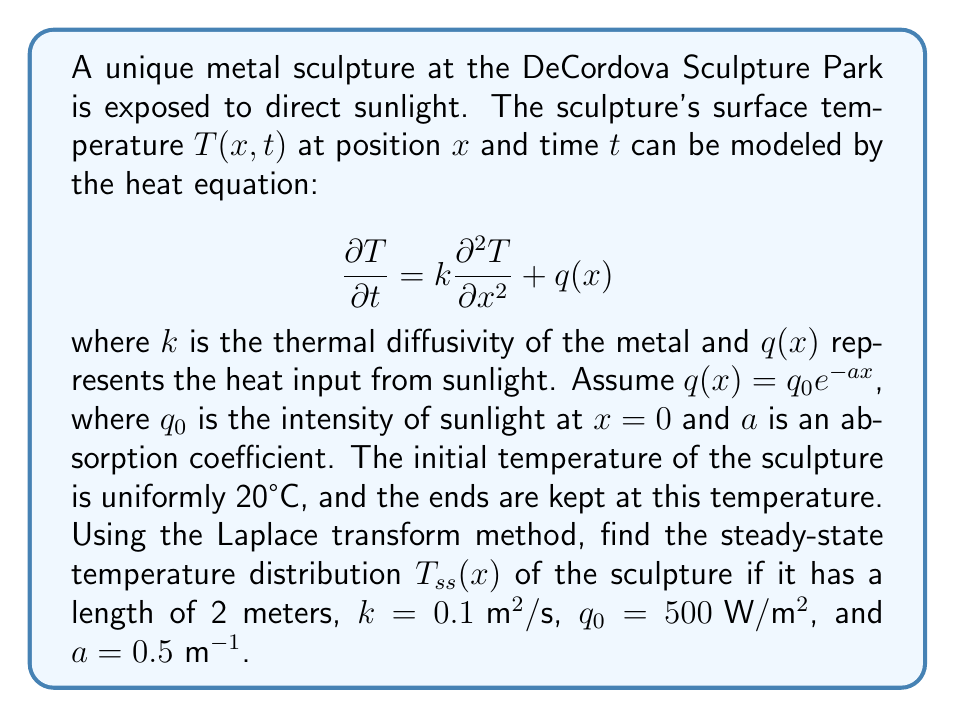Could you help me with this problem? To solve this problem, we'll follow these steps:

1) First, we need to find the steady-state equation by setting $\frac{\partial T}{\partial t} = 0$:

   $$0 = k\frac{d^2 T_{ss}}{dx^2} + q_0e^{-ax}$$

2) Rearranging the equation:

   $$\frac{d^2 T_{ss}}{dx^2} = -\frac{q_0}{k}e^{-ax}$$

3) Taking the Laplace transform of both sides with respect to $x$:

   $$s^2\mathcal{L}\{T_{ss}\} - sT_{ss}(0) - T_{ss}'(0) = -\frac{q_0}{k}\mathcal{L}\{e^{-ax}\}$$

4) We know that $\mathcal{L}\{e^{-ax}\} = \frac{1}{s+a}$, so:

   $$s^2\mathcal{L}\{T_{ss}\} - sT_{ss}(0) - T_{ss}'(0) = -\frac{q_0}{k}\frac{1}{s+a}$$

5) Solving for $\mathcal{L}\{T_{ss}\}$:

   $$\mathcal{L}\{T_{ss}\} = \frac{T_{ss}(0)}{s} + \frac{T_{ss}'(0)}{s^2} + \frac{q_0}{k}\frac{1}{s^2(s+a)}$$

6) Taking the inverse Laplace transform:

   $$T_{ss}(x) = T_{ss}(0) + T_{ss}'(0)x + \frac{q_0}{ka^2}(1 - e^{-ax} - ax)$$

7) We know that $T_{ss}(0) = T_{ss}(2) = 20$ (boundary conditions). Using these:

   $$20 = 20 + 2T_{ss}'(0) + \frac{q_0}{ka^2}(1 - e^{-2a} - 2a)$$

8) Solving for $T_{ss}'(0)$:

   $$T_{ss}'(0) = -\frac{q_0}{2ka^2}(1 - e^{-2a} - 2a)$$

9) Substituting back into the general solution:

   $$T_{ss}(x) = 20 - \frac{q_0}{2ka^2}(1 - e^{-2a} - 2a)x + \frac{q_0}{ka^2}(1 - e^{-ax} - ax)$$

10) Now we can substitute the given values: $k = 0.1$, $q_0 = 500$, $a = 0.5$

    $$T_{ss}(x) = 20 - 1000(1 - e^{-1} - 1)x + 2000(1 - e^{-0.5x} - 0.5x)$$

This is the steady-state temperature distribution of the sculpture.
Answer: $$T_{ss}(x) = 20 - 1000(1 - e^{-1} - 1)x + 2000(1 - e^{-0.5x} - 0.5x)$$
where $x$ is the position along the sculpture in meters, and $T_{ss}(x)$ is the steady-state temperature in °C. 